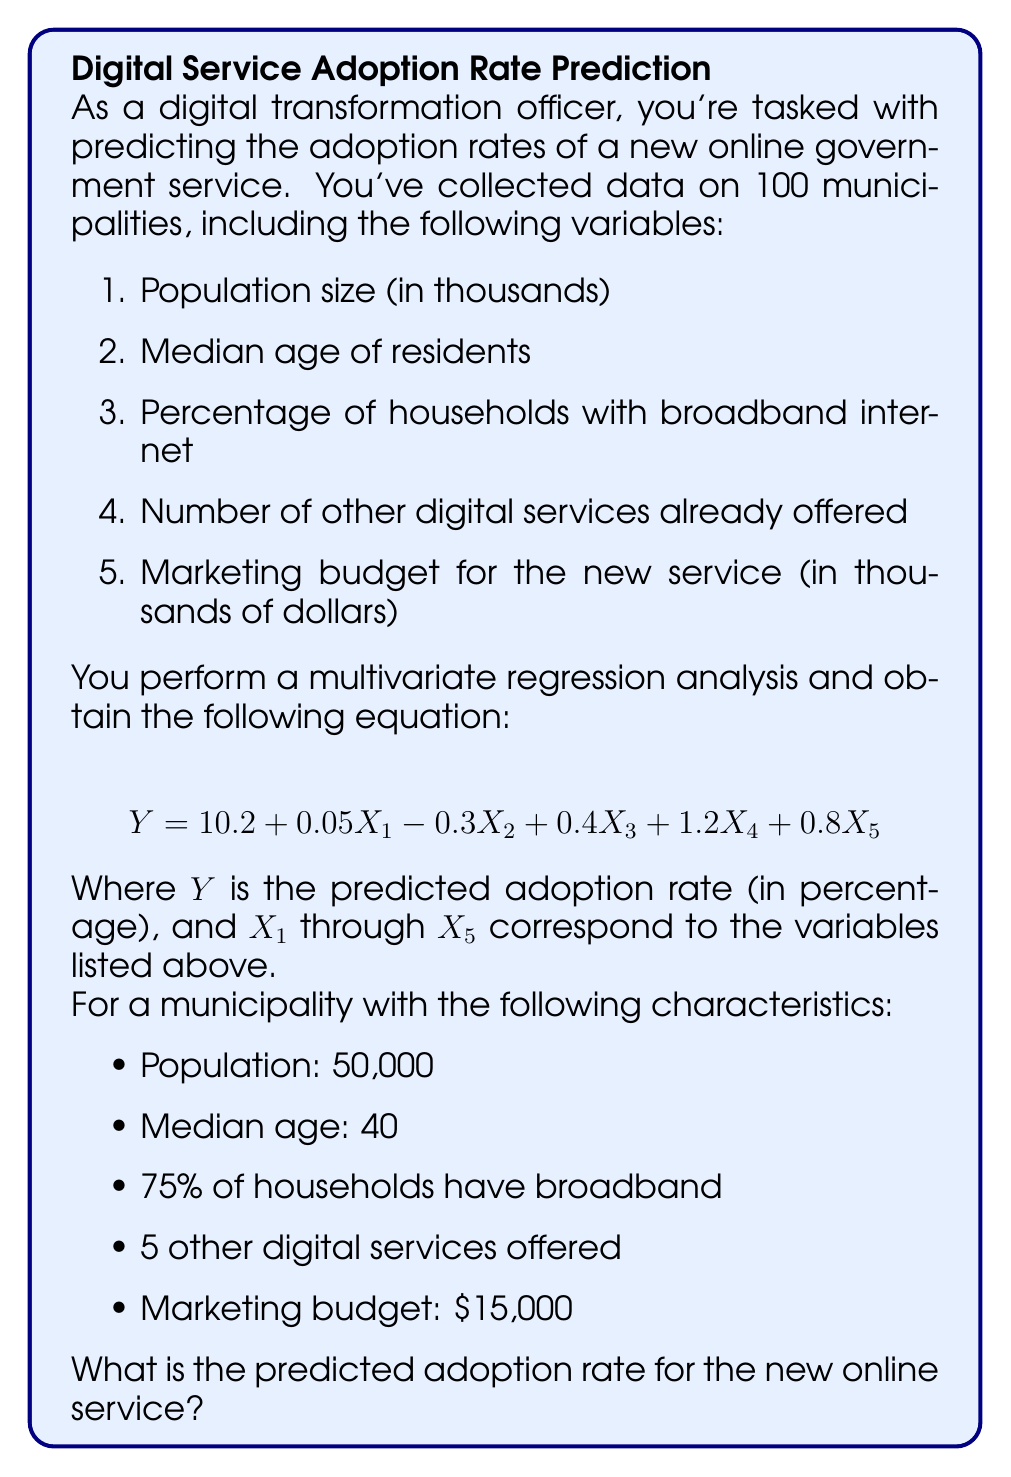Teach me how to tackle this problem. To solve this problem, we need to follow these steps:

1. Identify the values for each variable:
   $X_1 = 50$ (population in thousands)
   $X_2 = 40$ (median age)
   $X_3 = 75$ (percentage with broadband)
   $X_4 = 5$ (number of other digital services)
   $X_5 = 15$ (marketing budget in thousands)

2. Substitute these values into the regression equation:

   $$ Y = 10.2 + 0.05X_1 - 0.3X_2 + 0.4X_3 + 1.2X_4 + 0.8X_5 $$

3. Calculate each term:
   $10.2$ (constant term)
   $0.05 * 50 = 2.5$
   $-0.3 * 40 = -12$
   $0.4 * 75 = 30$
   $1.2 * 5 = 6$
   $0.8 * 15 = 12$

4. Sum up all the terms:
   $$ Y = 10.2 + 2.5 - 12 + 30 + 6 + 12 $$

5. Compute the final result:
   $$ Y = 48.7 $$

The predicted adoption rate is 48.7%.
Answer: 48.7% 